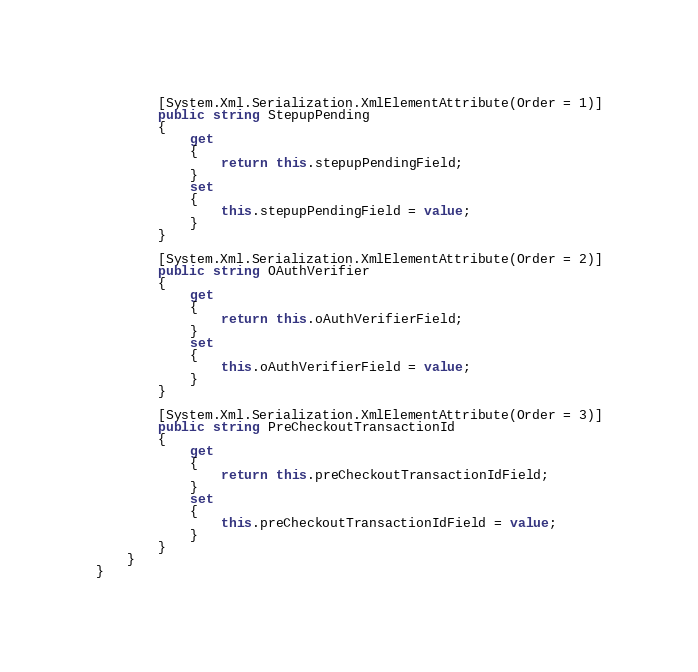<code> <loc_0><loc_0><loc_500><loc_500><_C#_>        [System.Xml.Serialization.XmlElementAttribute(Order = 1)]
        public string StepupPending
        {
            get
            {
                return this.stepupPendingField;
            }
            set
            {
                this.stepupPendingField = value;
            }
        }

        [System.Xml.Serialization.XmlElementAttribute(Order = 2)]
        public string OAuthVerifier
        {
            get
            {
                return this.oAuthVerifierField;
            }
            set
            {
                this.oAuthVerifierField = value;
            }
        }

        [System.Xml.Serialization.XmlElementAttribute(Order = 3)]
        public string PreCheckoutTransactionId
        {
            get
            {
                return this.preCheckoutTransactionIdField;
            }
            set
            {
                this.preCheckoutTransactionIdField = value;
            }
        }
    }
}
</code> 